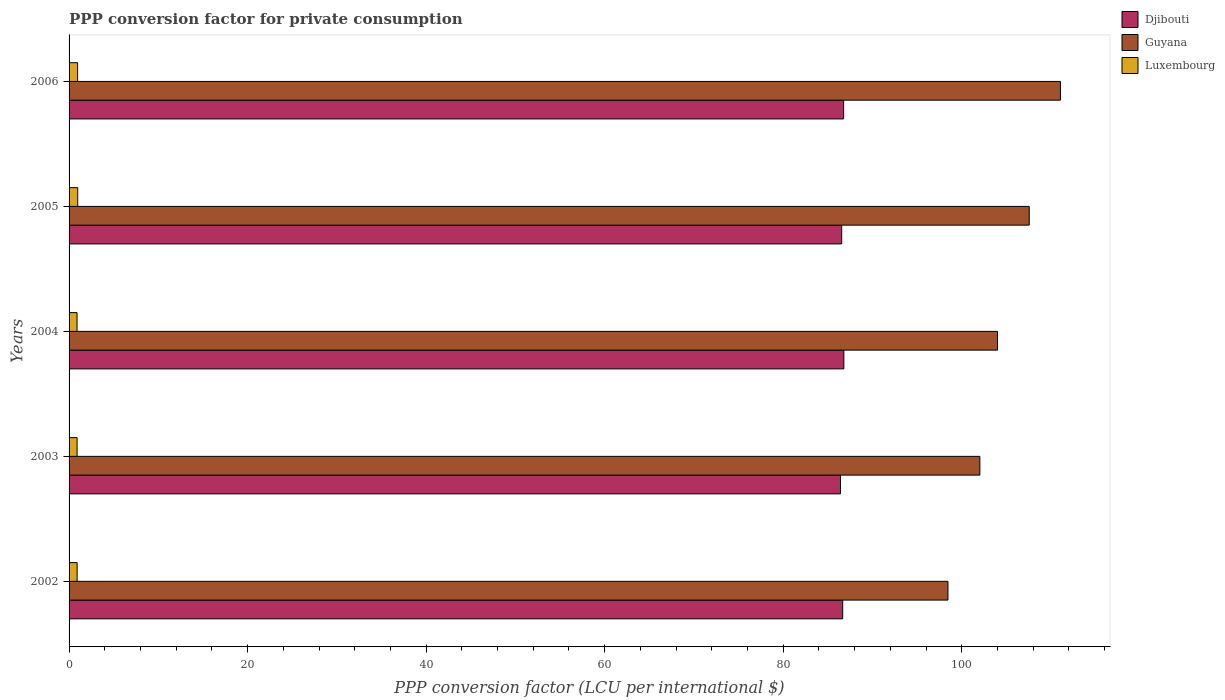How many different coloured bars are there?
Provide a succinct answer. 3. Are the number of bars per tick equal to the number of legend labels?
Your answer should be very brief. Yes. Are the number of bars on each tick of the Y-axis equal?
Keep it short and to the point. Yes. How many bars are there on the 1st tick from the top?
Keep it short and to the point. 3. How many bars are there on the 2nd tick from the bottom?
Provide a succinct answer. 3. What is the label of the 5th group of bars from the top?
Your answer should be compact. 2002. In how many cases, is the number of bars for a given year not equal to the number of legend labels?
Provide a succinct answer. 0. What is the PPP conversion factor for private consumption in Luxembourg in 2004?
Keep it short and to the point. 0.89. Across all years, what is the maximum PPP conversion factor for private consumption in Guyana?
Make the answer very short. 111.05. Across all years, what is the minimum PPP conversion factor for private consumption in Luxembourg?
Keep it short and to the point. 0.89. In which year was the PPP conversion factor for private consumption in Luxembourg maximum?
Offer a terse response. 2005. In which year was the PPP conversion factor for private consumption in Guyana minimum?
Give a very brief answer. 2002. What is the total PPP conversion factor for private consumption in Guyana in the graph?
Offer a terse response. 523.1. What is the difference between the PPP conversion factor for private consumption in Guyana in 2002 and that in 2006?
Your response must be concise. -12.6. What is the difference between the PPP conversion factor for private consumption in Guyana in 2006 and the PPP conversion factor for private consumption in Luxembourg in 2005?
Give a very brief answer. 110.08. What is the average PPP conversion factor for private consumption in Luxembourg per year?
Your answer should be very brief. 0.92. In the year 2003, what is the difference between the PPP conversion factor for private consumption in Luxembourg and PPP conversion factor for private consumption in Guyana?
Your response must be concise. -101.13. What is the ratio of the PPP conversion factor for private consumption in Djibouti in 2004 to that in 2005?
Your answer should be very brief. 1. What is the difference between the highest and the second highest PPP conversion factor for private consumption in Guyana?
Your answer should be very brief. 3.49. What is the difference between the highest and the lowest PPP conversion factor for private consumption in Guyana?
Give a very brief answer. 12.6. In how many years, is the PPP conversion factor for private consumption in Luxembourg greater than the average PPP conversion factor for private consumption in Luxembourg taken over all years?
Your response must be concise. 2. What does the 1st bar from the top in 2003 represents?
Provide a succinct answer. Luxembourg. What does the 2nd bar from the bottom in 2004 represents?
Your answer should be compact. Guyana. Is it the case that in every year, the sum of the PPP conversion factor for private consumption in Djibouti and PPP conversion factor for private consumption in Guyana is greater than the PPP conversion factor for private consumption in Luxembourg?
Keep it short and to the point. Yes. What is the difference between two consecutive major ticks on the X-axis?
Provide a succinct answer. 20. Where does the legend appear in the graph?
Provide a short and direct response. Top right. How many legend labels are there?
Your answer should be very brief. 3. What is the title of the graph?
Keep it short and to the point. PPP conversion factor for private consumption. Does "Guinea" appear as one of the legend labels in the graph?
Give a very brief answer. No. What is the label or title of the X-axis?
Keep it short and to the point. PPP conversion factor (LCU per international $). What is the PPP conversion factor (LCU per international $) in Djibouti in 2002?
Your response must be concise. 86.66. What is the PPP conversion factor (LCU per international $) of Guyana in 2002?
Give a very brief answer. 98.46. What is the PPP conversion factor (LCU per international $) of Luxembourg in 2002?
Your answer should be very brief. 0.9. What is the PPP conversion factor (LCU per international $) of Djibouti in 2003?
Your response must be concise. 86.42. What is the PPP conversion factor (LCU per international $) in Guyana in 2003?
Provide a short and direct response. 102.03. What is the PPP conversion factor (LCU per international $) in Luxembourg in 2003?
Give a very brief answer. 0.9. What is the PPP conversion factor (LCU per international $) in Djibouti in 2004?
Offer a terse response. 86.79. What is the PPP conversion factor (LCU per international $) of Guyana in 2004?
Your response must be concise. 104.01. What is the PPP conversion factor (LCU per international $) of Luxembourg in 2004?
Offer a terse response. 0.89. What is the PPP conversion factor (LCU per international $) of Djibouti in 2005?
Make the answer very short. 86.55. What is the PPP conversion factor (LCU per international $) in Guyana in 2005?
Your response must be concise. 107.56. What is the PPP conversion factor (LCU per international $) of Luxembourg in 2005?
Provide a succinct answer. 0.97. What is the PPP conversion factor (LCU per international $) of Djibouti in 2006?
Offer a very short reply. 86.77. What is the PPP conversion factor (LCU per international $) in Guyana in 2006?
Keep it short and to the point. 111.05. What is the PPP conversion factor (LCU per international $) in Luxembourg in 2006?
Make the answer very short. 0.96. Across all years, what is the maximum PPP conversion factor (LCU per international $) in Djibouti?
Offer a terse response. 86.79. Across all years, what is the maximum PPP conversion factor (LCU per international $) of Guyana?
Give a very brief answer. 111.05. Across all years, what is the maximum PPP conversion factor (LCU per international $) in Luxembourg?
Your response must be concise. 0.97. Across all years, what is the minimum PPP conversion factor (LCU per international $) of Djibouti?
Ensure brevity in your answer.  86.42. Across all years, what is the minimum PPP conversion factor (LCU per international $) of Guyana?
Provide a short and direct response. 98.46. Across all years, what is the minimum PPP conversion factor (LCU per international $) in Luxembourg?
Give a very brief answer. 0.89. What is the total PPP conversion factor (LCU per international $) of Djibouti in the graph?
Keep it short and to the point. 433.19. What is the total PPP conversion factor (LCU per international $) in Guyana in the graph?
Your answer should be very brief. 523.1. What is the total PPP conversion factor (LCU per international $) of Luxembourg in the graph?
Provide a succinct answer. 4.62. What is the difference between the PPP conversion factor (LCU per international $) in Djibouti in 2002 and that in 2003?
Your answer should be very brief. 0.24. What is the difference between the PPP conversion factor (LCU per international $) of Guyana in 2002 and that in 2003?
Offer a terse response. -3.57. What is the difference between the PPP conversion factor (LCU per international $) in Luxembourg in 2002 and that in 2003?
Offer a very short reply. 0. What is the difference between the PPP conversion factor (LCU per international $) of Djibouti in 2002 and that in 2004?
Keep it short and to the point. -0.13. What is the difference between the PPP conversion factor (LCU per international $) of Guyana in 2002 and that in 2004?
Your response must be concise. -5.55. What is the difference between the PPP conversion factor (LCU per international $) in Luxembourg in 2002 and that in 2004?
Make the answer very short. 0.01. What is the difference between the PPP conversion factor (LCU per international $) of Djibouti in 2002 and that in 2005?
Keep it short and to the point. 0.11. What is the difference between the PPP conversion factor (LCU per international $) in Guyana in 2002 and that in 2005?
Offer a terse response. -9.1. What is the difference between the PPP conversion factor (LCU per international $) in Luxembourg in 2002 and that in 2005?
Keep it short and to the point. -0.07. What is the difference between the PPP conversion factor (LCU per international $) in Djibouti in 2002 and that in 2006?
Ensure brevity in your answer.  -0.1. What is the difference between the PPP conversion factor (LCU per international $) of Guyana in 2002 and that in 2006?
Make the answer very short. -12.6. What is the difference between the PPP conversion factor (LCU per international $) in Luxembourg in 2002 and that in 2006?
Keep it short and to the point. -0.05. What is the difference between the PPP conversion factor (LCU per international $) of Djibouti in 2003 and that in 2004?
Keep it short and to the point. -0.37. What is the difference between the PPP conversion factor (LCU per international $) in Guyana in 2003 and that in 2004?
Ensure brevity in your answer.  -1.98. What is the difference between the PPP conversion factor (LCU per international $) in Luxembourg in 2003 and that in 2004?
Provide a succinct answer. 0.01. What is the difference between the PPP conversion factor (LCU per international $) in Djibouti in 2003 and that in 2005?
Make the answer very short. -0.13. What is the difference between the PPP conversion factor (LCU per international $) in Guyana in 2003 and that in 2005?
Provide a succinct answer. -5.53. What is the difference between the PPP conversion factor (LCU per international $) in Luxembourg in 2003 and that in 2005?
Offer a very short reply. -0.07. What is the difference between the PPP conversion factor (LCU per international $) in Djibouti in 2003 and that in 2006?
Offer a very short reply. -0.35. What is the difference between the PPP conversion factor (LCU per international $) of Guyana in 2003 and that in 2006?
Give a very brief answer. -9.03. What is the difference between the PPP conversion factor (LCU per international $) of Luxembourg in 2003 and that in 2006?
Give a very brief answer. -0.06. What is the difference between the PPP conversion factor (LCU per international $) of Djibouti in 2004 and that in 2005?
Provide a succinct answer. 0.24. What is the difference between the PPP conversion factor (LCU per international $) of Guyana in 2004 and that in 2005?
Offer a very short reply. -3.55. What is the difference between the PPP conversion factor (LCU per international $) in Luxembourg in 2004 and that in 2005?
Provide a short and direct response. -0.08. What is the difference between the PPP conversion factor (LCU per international $) in Djibouti in 2004 and that in 2006?
Your answer should be compact. 0.03. What is the difference between the PPP conversion factor (LCU per international $) of Guyana in 2004 and that in 2006?
Provide a succinct answer. -7.05. What is the difference between the PPP conversion factor (LCU per international $) of Luxembourg in 2004 and that in 2006?
Offer a very short reply. -0.06. What is the difference between the PPP conversion factor (LCU per international $) of Djibouti in 2005 and that in 2006?
Provide a short and direct response. -0.22. What is the difference between the PPP conversion factor (LCU per international $) of Guyana in 2005 and that in 2006?
Your response must be concise. -3.49. What is the difference between the PPP conversion factor (LCU per international $) of Luxembourg in 2005 and that in 2006?
Ensure brevity in your answer.  0.01. What is the difference between the PPP conversion factor (LCU per international $) in Djibouti in 2002 and the PPP conversion factor (LCU per international $) in Guyana in 2003?
Make the answer very short. -15.37. What is the difference between the PPP conversion factor (LCU per international $) in Djibouti in 2002 and the PPP conversion factor (LCU per international $) in Luxembourg in 2003?
Keep it short and to the point. 85.76. What is the difference between the PPP conversion factor (LCU per international $) in Guyana in 2002 and the PPP conversion factor (LCU per international $) in Luxembourg in 2003?
Keep it short and to the point. 97.56. What is the difference between the PPP conversion factor (LCU per international $) in Djibouti in 2002 and the PPP conversion factor (LCU per international $) in Guyana in 2004?
Your response must be concise. -17.34. What is the difference between the PPP conversion factor (LCU per international $) in Djibouti in 2002 and the PPP conversion factor (LCU per international $) in Luxembourg in 2004?
Your answer should be compact. 85.77. What is the difference between the PPP conversion factor (LCU per international $) of Guyana in 2002 and the PPP conversion factor (LCU per international $) of Luxembourg in 2004?
Offer a terse response. 97.56. What is the difference between the PPP conversion factor (LCU per international $) of Djibouti in 2002 and the PPP conversion factor (LCU per international $) of Guyana in 2005?
Give a very brief answer. -20.9. What is the difference between the PPP conversion factor (LCU per international $) of Djibouti in 2002 and the PPP conversion factor (LCU per international $) of Luxembourg in 2005?
Offer a very short reply. 85.69. What is the difference between the PPP conversion factor (LCU per international $) of Guyana in 2002 and the PPP conversion factor (LCU per international $) of Luxembourg in 2005?
Your answer should be compact. 97.49. What is the difference between the PPP conversion factor (LCU per international $) of Djibouti in 2002 and the PPP conversion factor (LCU per international $) of Guyana in 2006?
Give a very brief answer. -24.39. What is the difference between the PPP conversion factor (LCU per international $) in Djibouti in 2002 and the PPP conversion factor (LCU per international $) in Luxembourg in 2006?
Make the answer very short. 85.71. What is the difference between the PPP conversion factor (LCU per international $) in Guyana in 2002 and the PPP conversion factor (LCU per international $) in Luxembourg in 2006?
Your answer should be very brief. 97.5. What is the difference between the PPP conversion factor (LCU per international $) in Djibouti in 2003 and the PPP conversion factor (LCU per international $) in Guyana in 2004?
Ensure brevity in your answer.  -17.59. What is the difference between the PPP conversion factor (LCU per international $) in Djibouti in 2003 and the PPP conversion factor (LCU per international $) in Luxembourg in 2004?
Your answer should be very brief. 85.53. What is the difference between the PPP conversion factor (LCU per international $) in Guyana in 2003 and the PPP conversion factor (LCU per international $) in Luxembourg in 2004?
Offer a very short reply. 101.14. What is the difference between the PPP conversion factor (LCU per international $) of Djibouti in 2003 and the PPP conversion factor (LCU per international $) of Guyana in 2005?
Your answer should be compact. -21.14. What is the difference between the PPP conversion factor (LCU per international $) of Djibouti in 2003 and the PPP conversion factor (LCU per international $) of Luxembourg in 2005?
Your response must be concise. 85.45. What is the difference between the PPP conversion factor (LCU per international $) in Guyana in 2003 and the PPP conversion factor (LCU per international $) in Luxembourg in 2005?
Provide a short and direct response. 101.06. What is the difference between the PPP conversion factor (LCU per international $) of Djibouti in 2003 and the PPP conversion factor (LCU per international $) of Guyana in 2006?
Give a very brief answer. -24.64. What is the difference between the PPP conversion factor (LCU per international $) in Djibouti in 2003 and the PPP conversion factor (LCU per international $) in Luxembourg in 2006?
Offer a very short reply. 85.46. What is the difference between the PPP conversion factor (LCU per international $) in Guyana in 2003 and the PPP conversion factor (LCU per international $) in Luxembourg in 2006?
Your answer should be compact. 101.07. What is the difference between the PPP conversion factor (LCU per international $) in Djibouti in 2004 and the PPP conversion factor (LCU per international $) in Guyana in 2005?
Give a very brief answer. -20.77. What is the difference between the PPP conversion factor (LCU per international $) in Djibouti in 2004 and the PPP conversion factor (LCU per international $) in Luxembourg in 2005?
Your answer should be compact. 85.82. What is the difference between the PPP conversion factor (LCU per international $) in Guyana in 2004 and the PPP conversion factor (LCU per international $) in Luxembourg in 2005?
Provide a short and direct response. 103.04. What is the difference between the PPP conversion factor (LCU per international $) of Djibouti in 2004 and the PPP conversion factor (LCU per international $) of Guyana in 2006?
Provide a succinct answer. -24.26. What is the difference between the PPP conversion factor (LCU per international $) in Djibouti in 2004 and the PPP conversion factor (LCU per international $) in Luxembourg in 2006?
Ensure brevity in your answer.  85.84. What is the difference between the PPP conversion factor (LCU per international $) in Guyana in 2004 and the PPP conversion factor (LCU per international $) in Luxembourg in 2006?
Provide a succinct answer. 103.05. What is the difference between the PPP conversion factor (LCU per international $) in Djibouti in 2005 and the PPP conversion factor (LCU per international $) in Guyana in 2006?
Make the answer very short. -24.5. What is the difference between the PPP conversion factor (LCU per international $) of Djibouti in 2005 and the PPP conversion factor (LCU per international $) of Luxembourg in 2006?
Offer a terse response. 85.6. What is the difference between the PPP conversion factor (LCU per international $) in Guyana in 2005 and the PPP conversion factor (LCU per international $) in Luxembourg in 2006?
Provide a short and direct response. 106.6. What is the average PPP conversion factor (LCU per international $) in Djibouti per year?
Your answer should be very brief. 86.64. What is the average PPP conversion factor (LCU per international $) of Guyana per year?
Your answer should be compact. 104.62. What is the average PPP conversion factor (LCU per international $) in Luxembourg per year?
Your answer should be compact. 0.92. In the year 2002, what is the difference between the PPP conversion factor (LCU per international $) in Djibouti and PPP conversion factor (LCU per international $) in Guyana?
Your answer should be very brief. -11.79. In the year 2002, what is the difference between the PPP conversion factor (LCU per international $) of Djibouti and PPP conversion factor (LCU per international $) of Luxembourg?
Your response must be concise. 85.76. In the year 2002, what is the difference between the PPP conversion factor (LCU per international $) of Guyana and PPP conversion factor (LCU per international $) of Luxembourg?
Your response must be concise. 97.55. In the year 2003, what is the difference between the PPP conversion factor (LCU per international $) of Djibouti and PPP conversion factor (LCU per international $) of Guyana?
Give a very brief answer. -15.61. In the year 2003, what is the difference between the PPP conversion factor (LCU per international $) in Djibouti and PPP conversion factor (LCU per international $) in Luxembourg?
Keep it short and to the point. 85.52. In the year 2003, what is the difference between the PPP conversion factor (LCU per international $) of Guyana and PPP conversion factor (LCU per international $) of Luxembourg?
Give a very brief answer. 101.13. In the year 2004, what is the difference between the PPP conversion factor (LCU per international $) of Djibouti and PPP conversion factor (LCU per international $) of Guyana?
Make the answer very short. -17.21. In the year 2004, what is the difference between the PPP conversion factor (LCU per international $) of Djibouti and PPP conversion factor (LCU per international $) of Luxembourg?
Keep it short and to the point. 85.9. In the year 2004, what is the difference between the PPP conversion factor (LCU per international $) of Guyana and PPP conversion factor (LCU per international $) of Luxembourg?
Provide a succinct answer. 103.11. In the year 2005, what is the difference between the PPP conversion factor (LCU per international $) of Djibouti and PPP conversion factor (LCU per international $) of Guyana?
Offer a terse response. -21.01. In the year 2005, what is the difference between the PPP conversion factor (LCU per international $) of Djibouti and PPP conversion factor (LCU per international $) of Luxembourg?
Keep it short and to the point. 85.58. In the year 2005, what is the difference between the PPP conversion factor (LCU per international $) of Guyana and PPP conversion factor (LCU per international $) of Luxembourg?
Offer a terse response. 106.59. In the year 2006, what is the difference between the PPP conversion factor (LCU per international $) of Djibouti and PPP conversion factor (LCU per international $) of Guyana?
Make the answer very short. -24.29. In the year 2006, what is the difference between the PPP conversion factor (LCU per international $) of Djibouti and PPP conversion factor (LCU per international $) of Luxembourg?
Give a very brief answer. 85.81. In the year 2006, what is the difference between the PPP conversion factor (LCU per international $) in Guyana and PPP conversion factor (LCU per international $) in Luxembourg?
Give a very brief answer. 110.1. What is the ratio of the PPP conversion factor (LCU per international $) of Djibouti in 2002 to that in 2003?
Keep it short and to the point. 1. What is the ratio of the PPP conversion factor (LCU per international $) of Guyana in 2002 to that in 2003?
Your answer should be very brief. 0.96. What is the ratio of the PPP conversion factor (LCU per international $) of Guyana in 2002 to that in 2004?
Offer a terse response. 0.95. What is the ratio of the PPP conversion factor (LCU per international $) in Luxembourg in 2002 to that in 2004?
Provide a succinct answer. 1.01. What is the ratio of the PPP conversion factor (LCU per international $) of Djibouti in 2002 to that in 2005?
Keep it short and to the point. 1. What is the ratio of the PPP conversion factor (LCU per international $) of Guyana in 2002 to that in 2005?
Give a very brief answer. 0.92. What is the ratio of the PPP conversion factor (LCU per international $) of Luxembourg in 2002 to that in 2005?
Keep it short and to the point. 0.93. What is the ratio of the PPP conversion factor (LCU per international $) of Djibouti in 2002 to that in 2006?
Provide a short and direct response. 1. What is the ratio of the PPP conversion factor (LCU per international $) of Guyana in 2002 to that in 2006?
Your answer should be compact. 0.89. What is the ratio of the PPP conversion factor (LCU per international $) of Luxembourg in 2002 to that in 2006?
Your response must be concise. 0.94. What is the ratio of the PPP conversion factor (LCU per international $) of Guyana in 2003 to that in 2005?
Provide a succinct answer. 0.95. What is the ratio of the PPP conversion factor (LCU per international $) in Luxembourg in 2003 to that in 2005?
Ensure brevity in your answer.  0.93. What is the ratio of the PPP conversion factor (LCU per international $) in Djibouti in 2003 to that in 2006?
Give a very brief answer. 1. What is the ratio of the PPP conversion factor (LCU per international $) of Guyana in 2003 to that in 2006?
Your answer should be very brief. 0.92. What is the ratio of the PPP conversion factor (LCU per international $) of Luxembourg in 2003 to that in 2006?
Your answer should be compact. 0.94. What is the ratio of the PPP conversion factor (LCU per international $) of Guyana in 2004 to that in 2005?
Your answer should be very brief. 0.97. What is the ratio of the PPP conversion factor (LCU per international $) of Luxembourg in 2004 to that in 2005?
Provide a short and direct response. 0.92. What is the ratio of the PPP conversion factor (LCU per international $) of Djibouti in 2004 to that in 2006?
Offer a terse response. 1. What is the ratio of the PPP conversion factor (LCU per international $) in Guyana in 2004 to that in 2006?
Make the answer very short. 0.94. What is the ratio of the PPP conversion factor (LCU per international $) of Luxembourg in 2004 to that in 2006?
Your answer should be compact. 0.93. What is the ratio of the PPP conversion factor (LCU per international $) of Djibouti in 2005 to that in 2006?
Keep it short and to the point. 1. What is the ratio of the PPP conversion factor (LCU per international $) of Guyana in 2005 to that in 2006?
Ensure brevity in your answer.  0.97. What is the difference between the highest and the second highest PPP conversion factor (LCU per international $) in Djibouti?
Provide a succinct answer. 0.03. What is the difference between the highest and the second highest PPP conversion factor (LCU per international $) of Guyana?
Offer a terse response. 3.49. What is the difference between the highest and the second highest PPP conversion factor (LCU per international $) in Luxembourg?
Your answer should be very brief. 0.01. What is the difference between the highest and the lowest PPP conversion factor (LCU per international $) of Djibouti?
Provide a short and direct response. 0.37. What is the difference between the highest and the lowest PPP conversion factor (LCU per international $) of Guyana?
Keep it short and to the point. 12.6. What is the difference between the highest and the lowest PPP conversion factor (LCU per international $) of Luxembourg?
Offer a terse response. 0.08. 